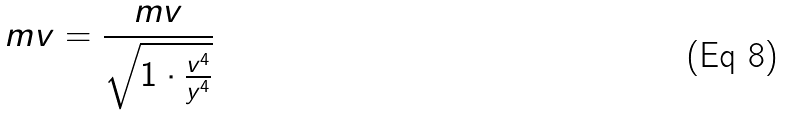Convert formula to latex. <formula><loc_0><loc_0><loc_500><loc_500>m v = \frac { m v } { \sqrt { 1 \cdot \frac { v ^ { 4 } } { y ^ { 4 } } } }</formula> 